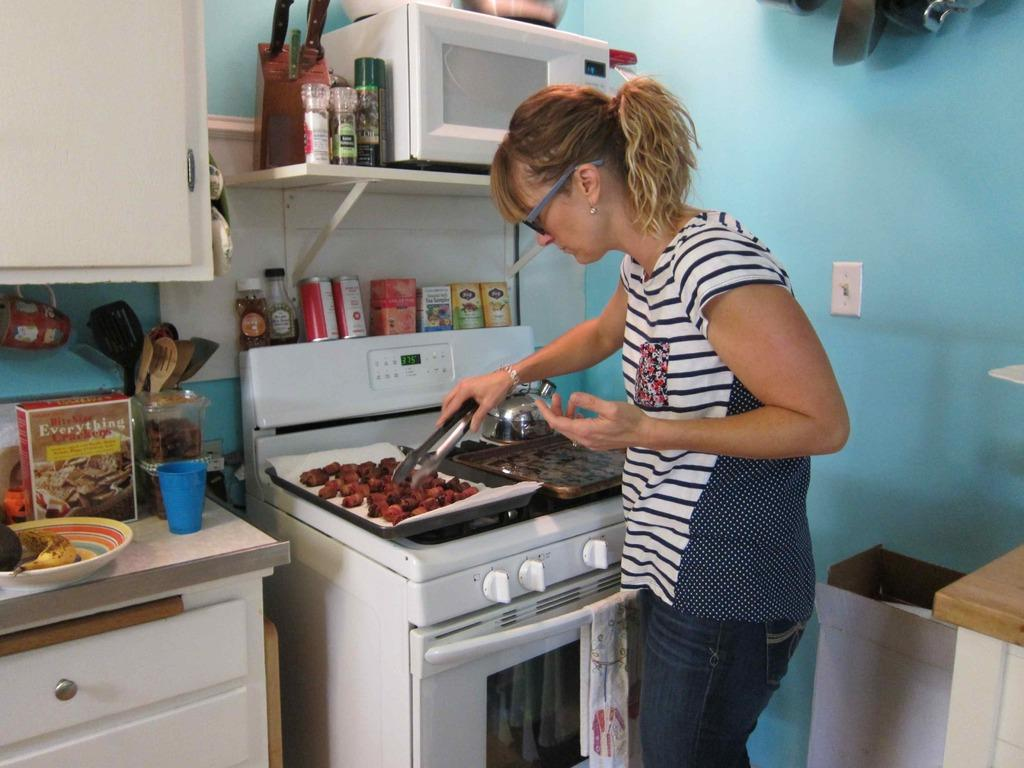<image>
Write a terse but informative summary of the picture. Woman cooking something with a box of "Everything Crackers" in the kitchen. 